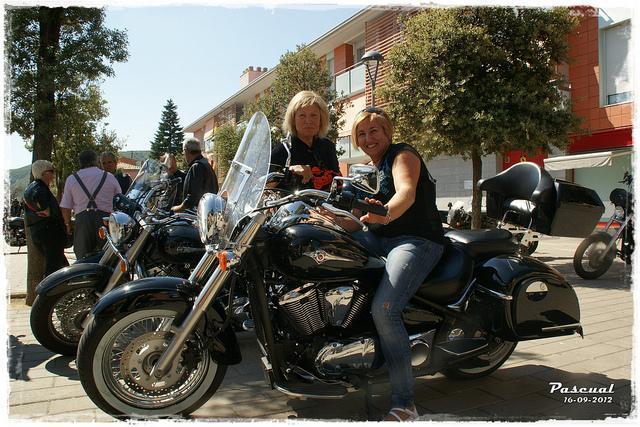How many motorcycles are in the photo?
Give a very brief answer. 3. How many people can be seen?
Give a very brief answer. 4. 